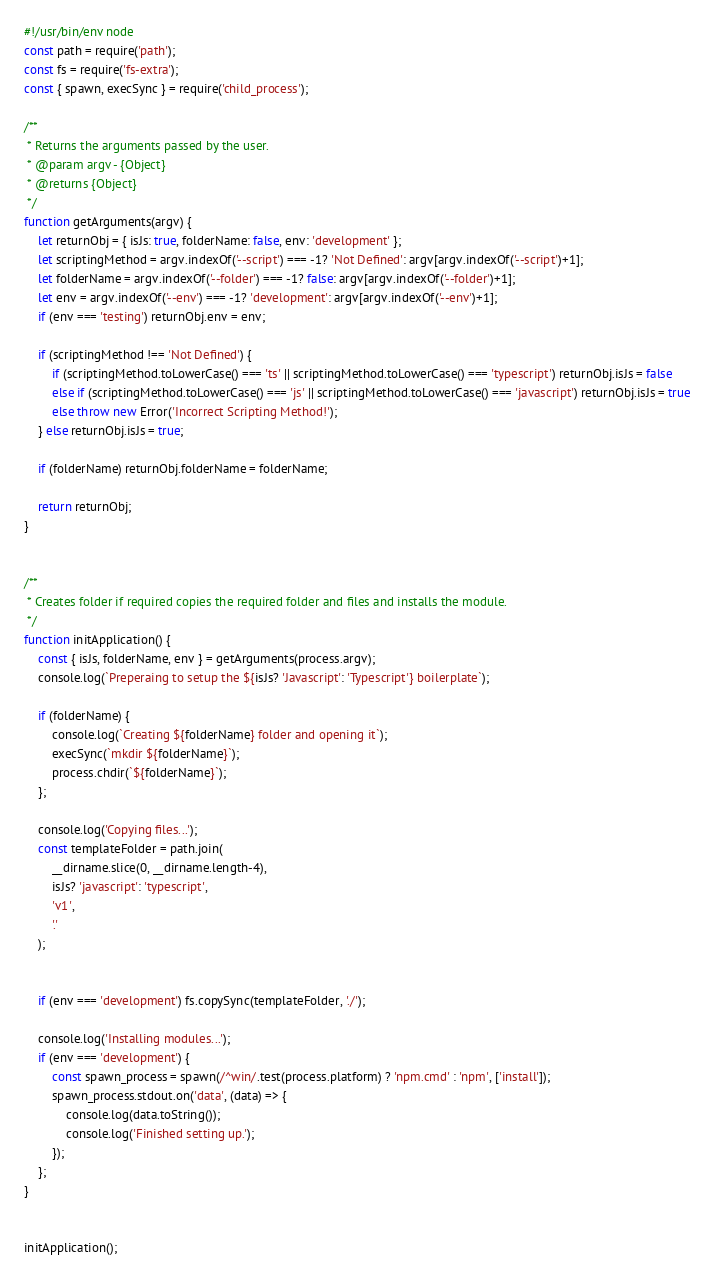<code> <loc_0><loc_0><loc_500><loc_500><_JavaScript_>#!/usr/bin/env node
const path = require('path');
const fs = require('fs-extra');
const { spawn, execSync } = require('child_process');

/**
 * Returns the arguments passed by the user.
 * @param argv - {Object} 
 * @returns {Object} 
 */
function getArguments(argv) {
    let returnObj = { isJs: true, folderName: false, env: 'development' };
    let scriptingMethod = argv.indexOf('--script') === -1? 'Not Defined': argv[argv.indexOf('--script')+1];
    let folderName = argv.indexOf('--folder') === -1? false: argv[argv.indexOf('--folder')+1];
    let env = argv.indexOf('--env') === -1? 'development': argv[argv.indexOf('--env')+1];
    if (env === 'testing') returnObj.env = env;
    
    if (scriptingMethod !== 'Not Defined') {
        if (scriptingMethod.toLowerCase() === 'ts' || scriptingMethod.toLowerCase() === 'typescript') returnObj.isJs = false
        else if (scriptingMethod.toLowerCase() === 'js' || scriptingMethod.toLowerCase() === 'javascript') returnObj.isJs = true
        else throw new Error('Incorrect Scripting Method!');
    } else returnObj.isJs = true;
    
    if (folderName) returnObj.folderName = folderName;
    
    return returnObj;
}


/**
 * Creates folder if required copies the required folder and files and installs the module.
 */
function initApplication() {
    const { isJs, folderName, env } = getArguments(process.argv);
    console.log(`Preperaing to setup the ${isJs? 'Javascript': 'Typescript'} boilerplate`);

    if (folderName) {
        console.log(`Creating ${folderName} folder and opening it`);
        execSync(`mkdir ${folderName}`);
        process.chdir(`${folderName}`);
    };

    console.log('Copying files...');
    const templateFolder = path.join(
        __dirname.slice(0, __dirname.length-4),
        isJs? 'javascript': 'typescript',
        'v1',
        '.'
    );

    
    if (env === 'development') fs.copySync(templateFolder, './');
    
    console.log('Installing modules...');
    if (env === 'development') {
        const spawn_process = spawn(/^win/.test(process.platform) ? 'npm.cmd' : 'npm', ['install']);
        spawn_process.stdout.on('data', (data) => {
            console.log(data.toString());
            console.log('Finished setting up.');
        });
    };
}


initApplication();</code> 